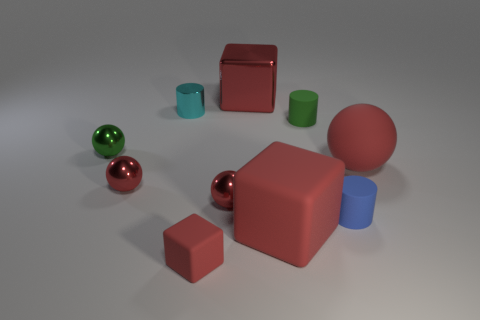Are there the same number of red rubber cubes that are left of the small red matte cube and small cyan metal cylinders to the left of the cyan metallic object?
Your answer should be compact. Yes. What number of yellow things are small cylinders or big shiny blocks?
Your answer should be very brief. 0. What number of green objects have the same size as the metallic cube?
Ensure brevity in your answer.  0. The metal thing that is both in front of the tiny cyan cylinder and right of the tiny cyan cylinder is what color?
Your answer should be compact. Red. Is the number of small cylinders that are in front of the large red ball greater than the number of small red shiny things?
Your answer should be compact. No. Is there a tiny shiny cylinder?
Your answer should be compact. Yes. Is the color of the large metal block the same as the large rubber cube?
Offer a terse response. Yes. How many small objects are metal things or cyan things?
Give a very brief answer. 4. Are there any other things that are the same color as the matte sphere?
Give a very brief answer. Yes. There is a large object that is the same material as the big red ball; what shape is it?
Your answer should be very brief. Cube. 